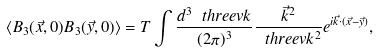Convert formula to latex. <formula><loc_0><loc_0><loc_500><loc_500>\langle B _ { 3 } ( \vec { x } , 0 ) B _ { 3 } ( \vec { y } , 0 ) \rangle = T \int \frac { d ^ { 3 } \ t h r e e v { k } } { ( 2 \pi ) ^ { 3 } } \frac { \vec { k } ^ { 2 } } { \ t h r e e v { k } ^ { 2 } } e ^ { i \vec { k } \cdot ( \vec { x } - \vec { y } ) } ,</formula> 